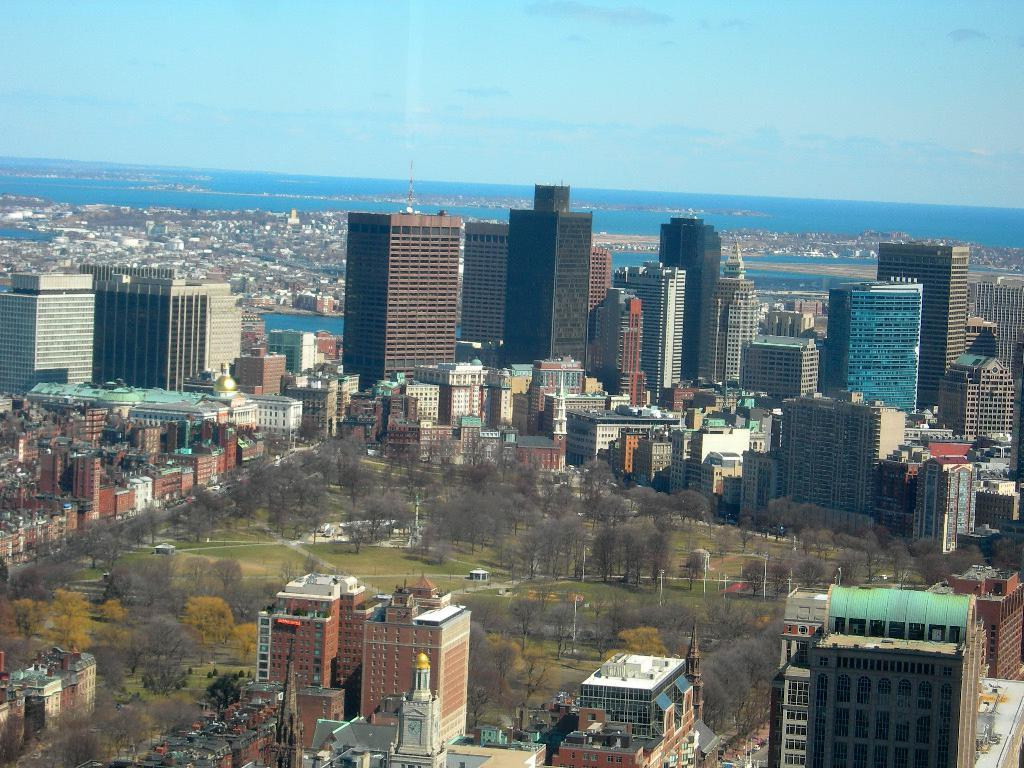What type of structures can be seen in the image? There are many buildings in the image, including a tower building. Are there any natural elements present in the image? Yes, there are gardens, trees, and water visible in the image. What can be seen in the background of the image? The sky is visible in the background of the image. Can you see a bear swimming in the river in the image? There is no bear or river present in the image. 